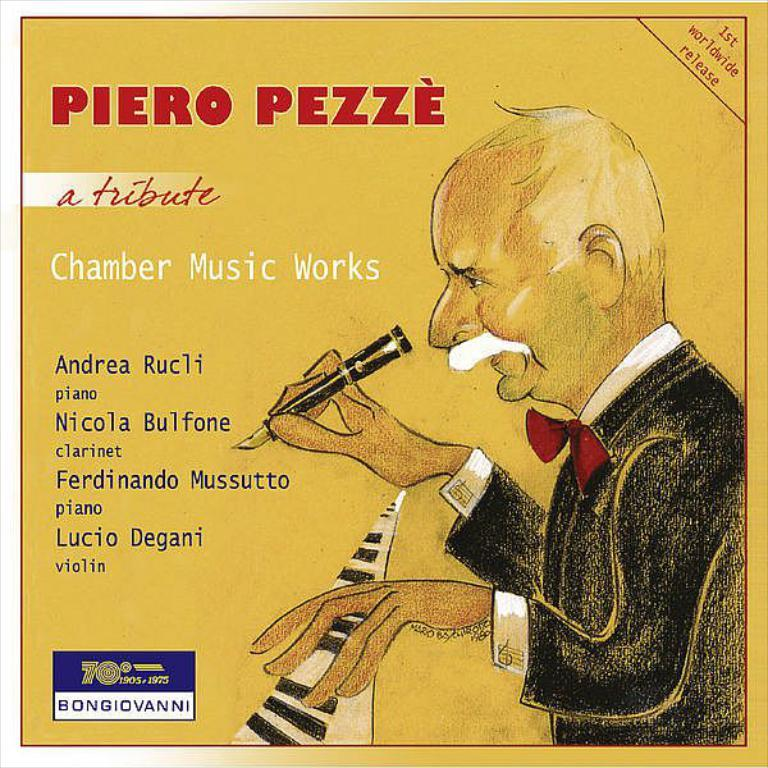Who or what is present in the image? There is a person in the image. What is the person holding in the image? The person is holding a pen. What can be observed about the text in the image? There are words written in the image. What type of visual medium is the image? The image is a poster. What type of popcorn is being served at the birthday party in the image? There is no mention of popcorn or a birthday party in the image; it features a person holding a pen and words written on a poster. 